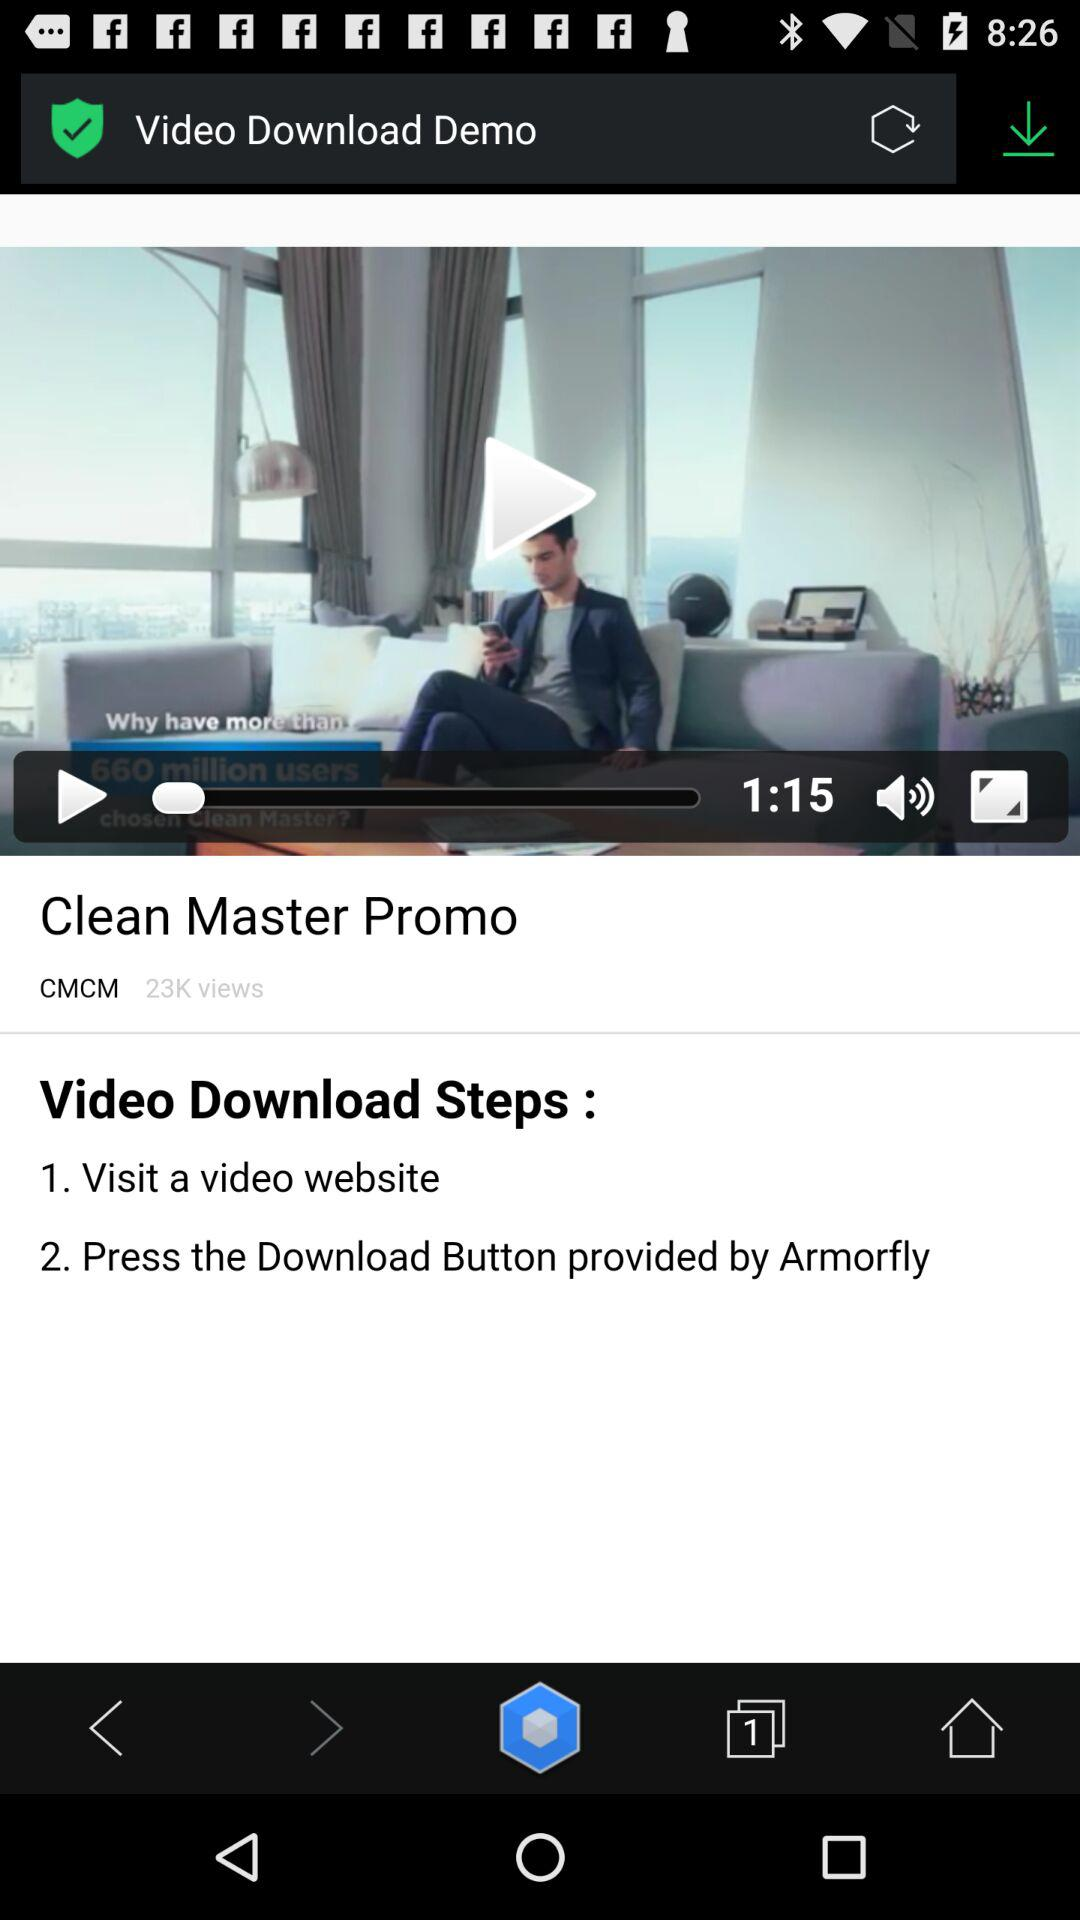How many views in total are there of the video? There are 23K views in total. 